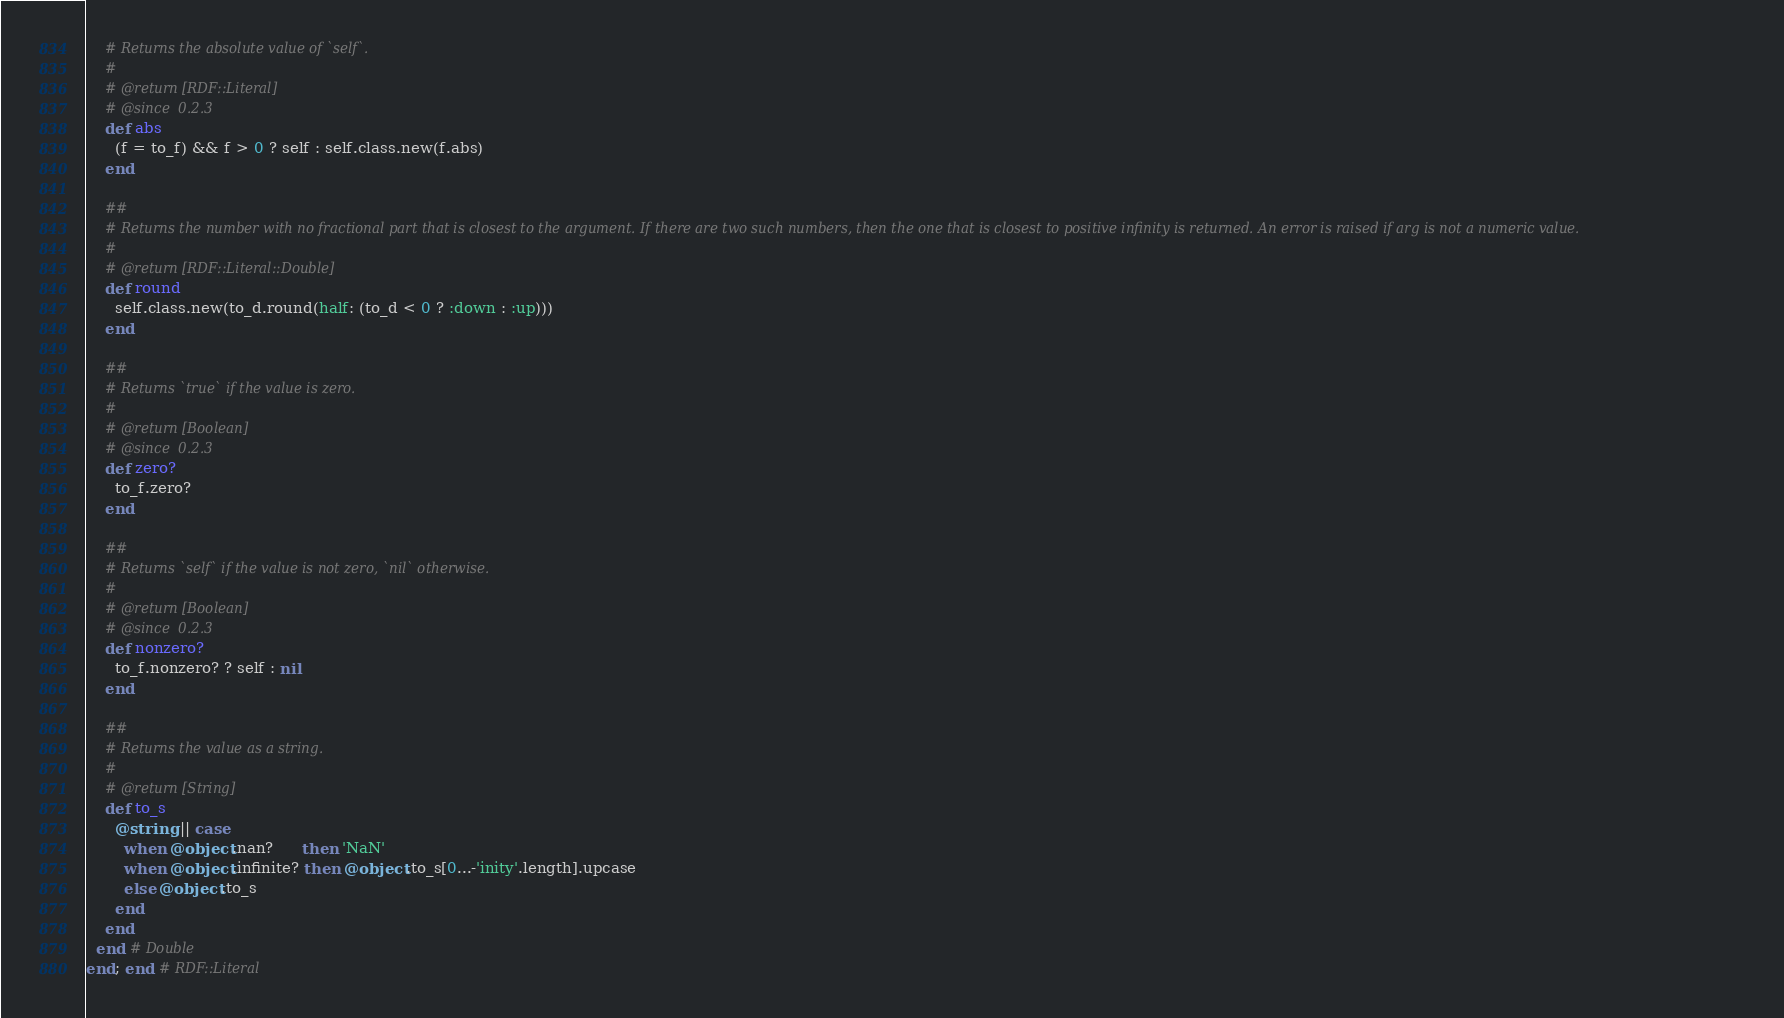<code> <loc_0><loc_0><loc_500><loc_500><_Ruby_>    # Returns the absolute value of `self`.
    #
    # @return [RDF::Literal]
    # @since  0.2.3
    def abs
      (f = to_f) && f > 0 ? self : self.class.new(f.abs)
    end

    ##
    # Returns the number with no fractional part that is closest to the argument. If there are two such numbers, then the one that is closest to positive infinity is returned. An error is raised if arg is not a numeric value.
    #
    # @return [RDF::Literal::Double]
    def round
      self.class.new(to_d.round(half: (to_d < 0 ? :down : :up)))
    end

    ##
    # Returns `true` if the value is zero.
    #
    # @return [Boolean]
    # @since  0.2.3
    def zero?
      to_f.zero?
    end

    ##
    # Returns `self` if the value is not zero, `nil` otherwise.
    #
    # @return [Boolean]
    # @since  0.2.3
    def nonzero?
      to_f.nonzero? ? self : nil
    end

    ##
    # Returns the value as a string.
    #
    # @return [String]
    def to_s
      @string || case
        when @object.nan?      then 'NaN'
        when @object.infinite? then @object.to_s[0...-'inity'.length].upcase
        else @object.to_s
      end
    end
  end # Double
end; end # RDF::Literal
</code> 